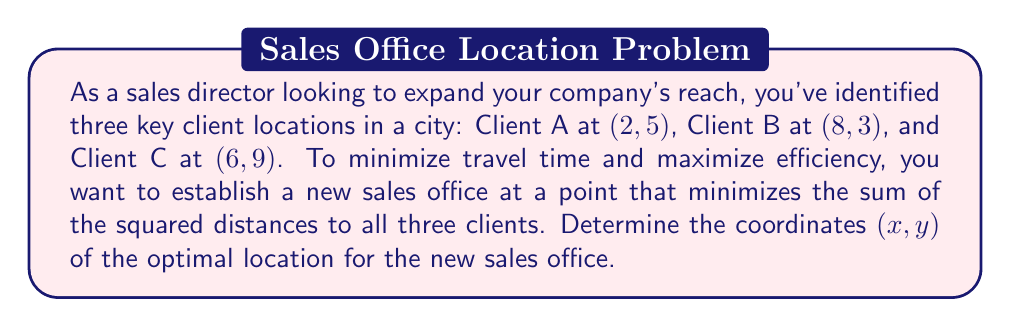Give your solution to this math problem. To solve this problem, we'll use the concept of the centroid in a coordinate system. The centroid minimizes the sum of squared distances to a set of points.

1) The formula for the centroid $(x_c, y_c)$ of $n$ points $(x_i, y_i)$ is:

   $$x_c = \frac{1}{n}\sum_{i=1}^n x_i$$
   $$y_c = \frac{1}{n}\sum_{i=1}^n y_i$$

2) In this case, we have three points:
   A(2, 5), B(8, 3), and C(6, 9)

3) Calculate $x_c$:
   $$x_c = \frac{1}{3}(2 + 8 + 6) = \frac{16}{3} \approx 5.33$$

4) Calculate $y_c$:
   $$y_c = \frac{1}{3}(5 + 3 + 9) = \frac{17}{3} \approx 5.67$$

5) Therefore, the optimal location for the new sales office is at the point $(\frac{16}{3}, \frac{17}{3})$.

This location minimizes the sum of squared distances to all three client locations, ensuring that your sales team can efficiently reach all clients and maximize productivity in the fast-paced city environment.
Answer: The optimal location for the new sales office is $(\frac{16}{3}, \frac{17}{3})$ or approximately (5.33, 5.67). 